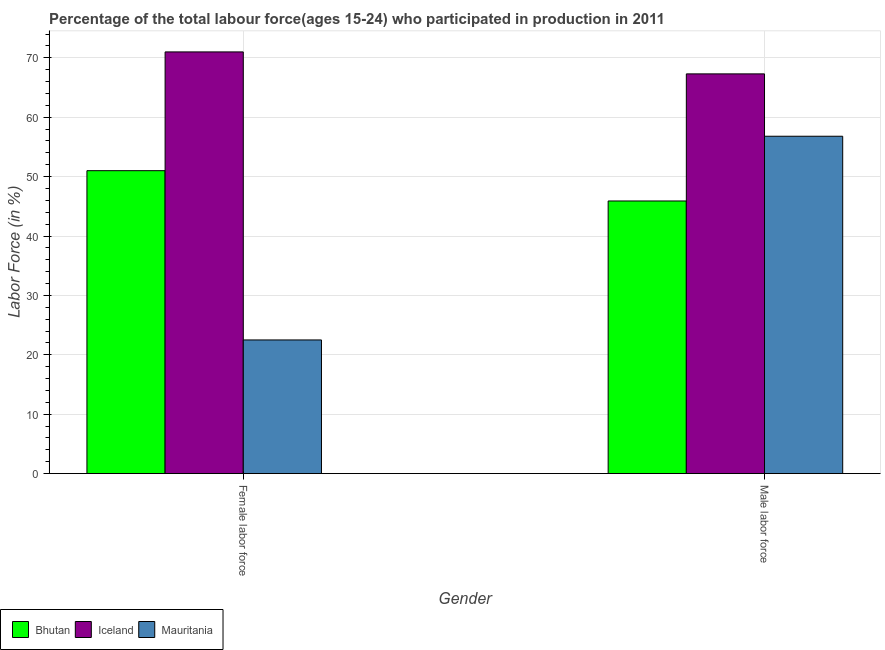Are the number of bars per tick equal to the number of legend labels?
Provide a short and direct response. Yes. Are the number of bars on each tick of the X-axis equal?
Offer a very short reply. Yes. How many bars are there on the 1st tick from the left?
Offer a terse response. 3. What is the label of the 2nd group of bars from the left?
Your response must be concise. Male labor force. What is the percentage of male labour force in Bhutan?
Make the answer very short. 45.9. Across all countries, what is the maximum percentage of male labour force?
Ensure brevity in your answer.  67.3. Across all countries, what is the minimum percentage of male labour force?
Make the answer very short. 45.9. In which country was the percentage of male labour force minimum?
Ensure brevity in your answer.  Bhutan. What is the total percentage of male labour force in the graph?
Your answer should be very brief. 170. What is the difference between the percentage of male labour force in Bhutan and that in Iceland?
Provide a short and direct response. -21.4. What is the difference between the percentage of female labor force in Mauritania and the percentage of male labour force in Bhutan?
Your response must be concise. -23.4. What is the average percentage of male labour force per country?
Keep it short and to the point. 56.67. What is the difference between the percentage of female labor force and percentage of male labour force in Bhutan?
Provide a short and direct response. 5.1. In how many countries, is the percentage of male labour force greater than 4 %?
Provide a short and direct response. 3. What is the ratio of the percentage of female labor force in Iceland to that in Mauritania?
Your answer should be very brief. 3.16. What does the 1st bar from the left in Male labor force represents?
Offer a very short reply. Bhutan. What does the 3rd bar from the right in Male labor force represents?
Ensure brevity in your answer.  Bhutan. How many bars are there?
Provide a succinct answer. 6. What is the difference between two consecutive major ticks on the Y-axis?
Your response must be concise. 10. Does the graph contain any zero values?
Your answer should be very brief. No. What is the title of the graph?
Your answer should be very brief. Percentage of the total labour force(ages 15-24) who participated in production in 2011. Does "United Arab Emirates" appear as one of the legend labels in the graph?
Your response must be concise. No. What is the label or title of the Y-axis?
Offer a very short reply. Labor Force (in %). What is the Labor Force (in %) in Bhutan in Female labor force?
Give a very brief answer. 51. What is the Labor Force (in %) in Mauritania in Female labor force?
Provide a succinct answer. 22.5. What is the Labor Force (in %) of Bhutan in Male labor force?
Give a very brief answer. 45.9. What is the Labor Force (in %) of Iceland in Male labor force?
Provide a succinct answer. 67.3. What is the Labor Force (in %) in Mauritania in Male labor force?
Offer a terse response. 56.8. Across all Gender, what is the maximum Labor Force (in %) in Iceland?
Make the answer very short. 71. Across all Gender, what is the maximum Labor Force (in %) of Mauritania?
Your answer should be very brief. 56.8. Across all Gender, what is the minimum Labor Force (in %) in Bhutan?
Keep it short and to the point. 45.9. Across all Gender, what is the minimum Labor Force (in %) of Iceland?
Offer a very short reply. 67.3. What is the total Labor Force (in %) of Bhutan in the graph?
Keep it short and to the point. 96.9. What is the total Labor Force (in %) in Iceland in the graph?
Give a very brief answer. 138.3. What is the total Labor Force (in %) in Mauritania in the graph?
Keep it short and to the point. 79.3. What is the difference between the Labor Force (in %) in Mauritania in Female labor force and that in Male labor force?
Offer a very short reply. -34.3. What is the difference between the Labor Force (in %) in Bhutan in Female labor force and the Labor Force (in %) in Iceland in Male labor force?
Provide a succinct answer. -16.3. What is the difference between the Labor Force (in %) of Iceland in Female labor force and the Labor Force (in %) of Mauritania in Male labor force?
Your response must be concise. 14.2. What is the average Labor Force (in %) in Bhutan per Gender?
Your answer should be very brief. 48.45. What is the average Labor Force (in %) of Iceland per Gender?
Keep it short and to the point. 69.15. What is the average Labor Force (in %) in Mauritania per Gender?
Offer a very short reply. 39.65. What is the difference between the Labor Force (in %) in Iceland and Labor Force (in %) in Mauritania in Female labor force?
Offer a very short reply. 48.5. What is the difference between the Labor Force (in %) of Bhutan and Labor Force (in %) of Iceland in Male labor force?
Ensure brevity in your answer.  -21.4. What is the difference between the Labor Force (in %) of Iceland and Labor Force (in %) of Mauritania in Male labor force?
Make the answer very short. 10.5. What is the ratio of the Labor Force (in %) in Bhutan in Female labor force to that in Male labor force?
Your answer should be very brief. 1.11. What is the ratio of the Labor Force (in %) in Iceland in Female labor force to that in Male labor force?
Provide a succinct answer. 1.05. What is the ratio of the Labor Force (in %) of Mauritania in Female labor force to that in Male labor force?
Offer a terse response. 0.4. What is the difference between the highest and the second highest Labor Force (in %) in Mauritania?
Your response must be concise. 34.3. What is the difference between the highest and the lowest Labor Force (in %) in Bhutan?
Offer a very short reply. 5.1. What is the difference between the highest and the lowest Labor Force (in %) in Iceland?
Your answer should be compact. 3.7. What is the difference between the highest and the lowest Labor Force (in %) in Mauritania?
Provide a succinct answer. 34.3. 